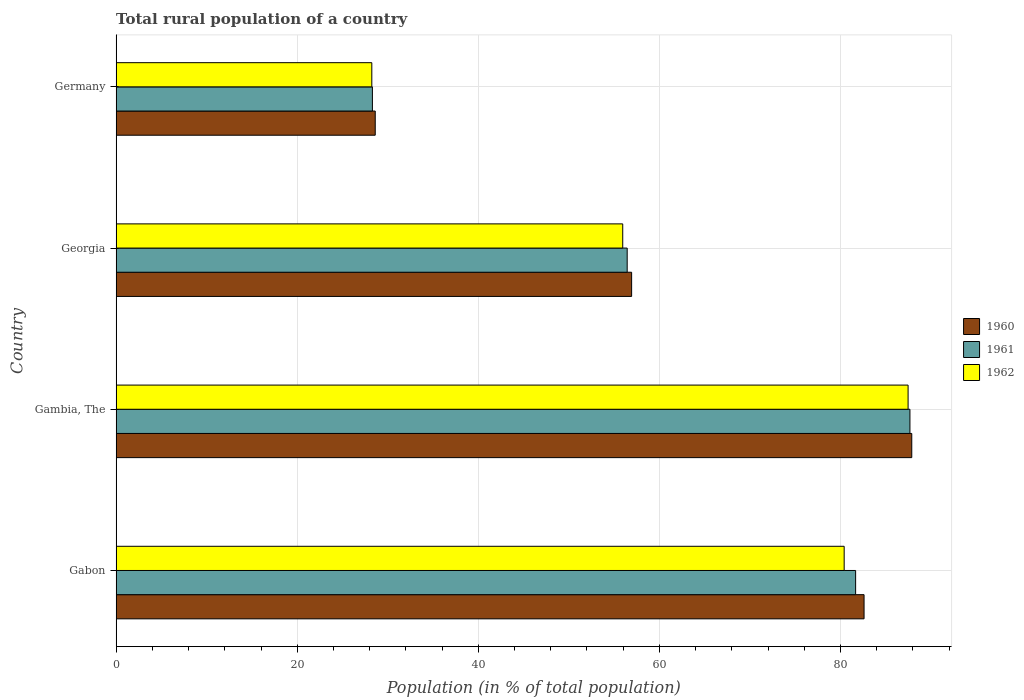How many different coloured bars are there?
Give a very brief answer. 3. How many groups of bars are there?
Your response must be concise. 4. Are the number of bars per tick equal to the number of legend labels?
Give a very brief answer. Yes. Are the number of bars on each tick of the Y-axis equal?
Ensure brevity in your answer.  Yes. How many bars are there on the 3rd tick from the top?
Your response must be concise. 3. How many bars are there on the 3rd tick from the bottom?
Ensure brevity in your answer.  3. What is the label of the 3rd group of bars from the top?
Offer a terse response. Gambia, The. What is the rural population in 1961 in Gambia, The?
Your answer should be compact. 87.67. Across all countries, what is the maximum rural population in 1962?
Your response must be concise. 87.47. Across all countries, what is the minimum rural population in 1962?
Offer a terse response. 28.24. In which country was the rural population in 1960 maximum?
Provide a short and direct response. Gambia, The. What is the total rural population in 1961 in the graph?
Your answer should be compact. 254.08. What is the difference between the rural population in 1962 in Gabon and that in Gambia, The?
Ensure brevity in your answer.  -7.06. What is the difference between the rural population in 1960 in Germany and the rural population in 1962 in Georgia?
Provide a short and direct response. -27.33. What is the average rural population in 1962 per country?
Keep it short and to the point. 63.01. What is the difference between the rural population in 1961 and rural population in 1960 in Germany?
Your response must be concise. -0.31. What is the ratio of the rural population in 1961 in Gabon to that in Georgia?
Offer a terse response. 1.45. Is the rural population in 1960 in Gabon less than that in Georgia?
Your answer should be compact. No. Is the difference between the rural population in 1961 in Gabon and Georgia greater than the difference between the rural population in 1960 in Gabon and Georgia?
Keep it short and to the point. No. What is the difference between the highest and the second highest rural population in 1960?
Ensure brevity in your answer.  5.27. What is the difference between the highest and the lowest rural population in 1961?
Keep it short and to the point. 59.37. In how many countries, is the rural population in 1960 greater than the average rural population in 1960 taken over all countries?
Your answer should be very brief. 2. How many bars are there?
Offer a terse response. 12. Are all the bars in the graph horizontal?
Make the answer very short. Yes. How many countries are there in the graph?
Your answer should be very brief. 4. Are the values on the major ticks of X-axis written in scientific E-notation?
Provide a short and direct response. No. Does the graph contain any zero values?
Your answer should be very brief. No. Does the graph contain grids?
Offer a very short reply. Yes. Where does the legend appear in the graph?
Ensure brevity in your answer.  Center right. How are the legend labels stacked?
Ensure brevity in your answer.  Vertical. What is the title of the graph?
Provide a succinct answer. Total rural population of a country. Does "1990" appear as one of the legend labels in the graph?
Make the answer very short. No. What is the label or title of the X-axis?
Ensure brevity in your answer.  Population (in % of total population). What is the Population (in % of total population) of 1960 in Gabon?
Keep it short and to the point. 82.6. What is the Population (in % of total population) in 1961 in Gabon?
Give a very brief answer. 81.67. What is the Population (in % of total population) of 1962 in Gabon?
Your response must be concise. 80.41. What is the Population (in % of total population) of 1960 in Gambia, The?
Offer a very short reply. 87.87. What is the Population (in % of total population) in 1961 in Gambia, The?
Provide a succinct answer. 87.67. What is the Population (in % of total population) in 1962 in Gambia, The?
Your answer should be very brief. 87.47. What is the Population (in % of total population) of 1960 in Georgia?
Ensure brevity in your answer.  56.93. What is the Population (in % of total population) in 1961 in Georgia?
Your answer should be very brief. 56.44. What is the Population (in % of total population) of 1962 in Georgia?
Give a very brief answer. 55.95. What is the Population (in % of total population) of 1960 in Germany?
Provide a short and direct response. 28.62. What is the Population (in % of total population) in 1961 in Germany?
Provide a succinct answer. 28.3. What is the Population (in % of total population) of 1962 in Germany?
Keep it short and to the point. 28.24. Across all countries, what is the maximum Population (in % of total population) of 1960?
Offer a terse response. 87.87. Across all countries, what is the maximum Population (in % of total population) in 1961?
Your answer should be compact. 87.67. Across all countries, what is the maximum Population (in % of total population) of 1962?
Your answer should be very brief. 87.47. Across all countries, what is the minimum Population (in % of total population) in 1960?
Make the answer very short. 28.62. Across all countries, what is the minimum Population (in % of total population) of 1961?
Make the answer very short. 28.3. Across all countries, what is the minimum Population (in % of total population) of 1962?
Ensure brevity in your answer.  28.24. What is the total Population (in % of total population) of 1960 in the graph?
Make the answer very short. 256.02. What is the total Population (in % of total population) of 1961 in the graph?
Give a very brief answer. 254.08. What is the total Population (in % of total population) in 1962 in the graph?
Your answer should be compact. 252.06. What is the difference between the Population (in % of total population) in 1960 in Gabon and that in Gambia, The?
Provide a short and direct response. -5.27. What is the difference between the Population (in % of total population) of 1961 in Gabon and that in Gambia, The?
Keep it short and to the point. -6. What is the difference between the Population (in % of total population) of 1962 in Gabon and that in Gambia, The?
Offer a very short reply. -7.06. What is the difference between the Population (in % of total population) in 1960 in Gabon and that in Georgia?
Your answer should be compact. 25.67. What is the difference between the Population (in % of total population) in 1961 in Gabon and that in Georgia?
Your answer should be compact. 25.23. What is the difference between the Population (in % of total population) of 1962 in Gabon and that in Georgia?
Keep it short and to the point. 24.46. What is the difference between the Population (in % of total population) of 1960 in Gabon and that in Germany?
Ensure brevity in your answer.  53.99. What is the difference between the Population (in % of total population) in 1961 in Gabon and that in Germany?
Your answer should be compact. 53.37. What is the difference between the Population (in % of total population) of 1962 in Gabon and that in Germany?
Make the answer very short. 52.17. What is the difference between the Population (in % of total population) of 1960 in Gambia, The and that in Georgia?
Keep it short and to the point. 30.94. What is the difference between the Population (in % of total population) in 1961 in Gambia, The and that in Georgia?
Offer a very short reply. 31.23. What is the difference between the Population (in % of total population) of 1962 in Gambia, The and that in Georgia?
Give a very brief answer. 31.52. What is the difference between the Population (in % of total population) in 1960 in Gambia, The and that in Germany?
Your answer should be compact. 59.26. What is the difference between the Population (in % of total population) in 1961 in Gambia, The and that in Germany?
Offer a terse response. 59.37. What is the difference between the Population (in % of total population) of 1962 in Gambia, The and that in Germany?
Keep it short and to the point. 59.23. What is the difference between the Population (in % of total population) of 1960 in Georgia and that in Germany?
Your answer should be compact. 28.32. What is the difference between the Population (in % of total population) of 1961 in Georgia and that in Germany?
Provide a short and direct response. 28.14. What is the difference between the Population (in % of total population) of 1962 in Georgia and that in Germany?
Offer a terse response. 27.71. What is the difference between the Population (in % of total population) in 1960 in Gabon and the Population (in % of total population) in 1961 in Gambia, The?
Offer a very short reply. -5.07. What is the difference between the Population (in % of total population) in 1960 in Gabon and the Population (in % of total population) in 1962 in Gambia, The?
Ensure brevity in your answer.  -4.86. What is the difference between the Population (in % of total population) in 1961 in Gabon and the Population (in % of total population) in 1962 in Gambia, The?
Make the answer very short. -5.79. What is the difference between the Population (in % of total population) of 1960 in Gabon and the Population (in % of total population) of 1961 in Georgia?
Ensure brevity in your answer.  26.16. What is the difference between the Population (in % of total population) of 1960 in Gabon and the Population (in % of total population) of 1962 in Georgia?
Your answer should be compact. 26.65. What is the difference between the Population (in % of total population) of 1961 in Gabon and the Population (in % of total population) of 1962 in Georgia?
Keep it short and to the point. 25.72. What is the difference between the Population (in % of total population) of 1960 in Gabon and the Population (in % of total population) of 1961 in Germany?
Your answer should be very brief. 54.3. What is the difference between the Population (in % of total population) of 1960 in Gabon and the Population (in % of total population) of 1962 in Germany?
Give a very brief answer. 54.36. What is the difference between the Population (in % of total population) in 1961 in Gabon and the Population (in % of total population) in 1962 in Germany?
Give a very brief answer. 53.43. What is the difference between the Population (in % of total population) of 1960 in Gambia, The and the Population (in % of total population) of 1961 in Georgia?
Your response must be concise. 31.43. What is the difference between the Population (in % of total population) of 1960 in Gambia, The and the Population (in % of total population) of 1962 in Georgia?
Your response must be concise. 31.92. What is the difference between the Population (in % of total population) of 1961 in Gambia, The and the Population (in % of total population) of 1962 in Georgia?
Keep it short and to the point. 31.72. What is the difference between the Population (in % of total population) of 1960 in Gambia, The and the Population (in % of total population) of 1961 in Germany?
Your answer should be very brief. 59.57. What is the difference between the Population (in % of total population) of 1960 in Gambia, The and the Population (in % of total population) of 1962 in Germany?
Offer a very short reply. 59.63. What is the difference between the Population (in % of total population) of 1961 in Gambia, The and the Population (in % of total population) of 1962 in Germany?
Your answer should be compact. 59.43. What is the difference between the Population (in % of total population) in 1960 in Georgia and the Population (in % of total population) in 1961 in Germany?
Give a very brief answer. 28.63. What is the difference between the Population (in % of total population) of 1960 in Georgia and the Population (in % of total population) of 1962 in Germany?
Provide a succinct answer. 28.69. What is the difference between the Population (in % of total population) in 1961 in Georgia and the Population (in % of total population) in 1962 in Germany?
Give a very brief answer. 28.2. What is the average Population (in % of total population) of 1960 per country?
Provide a succinct answer. 64. What is the average Population (in % of total population) of 1961 per country?
Your response must be concise. 63.52. What is the average Population (in % of total population) in 1962 per country?
Ensure brevity in your answer.  63.01. What is the difference between the Population (in % of total population) in 1960 and Population (in % of total population) in 1961 in Gabon?
Give a very brief answer. 0.93. What is the difference between the Population (in % of total population) of 1960 and Population (in % of total population) of 1962 in Gabon?
Your answer should be compact. 2.2. What is the difference between the Population (in % of total population) of 1961 and Population (in % of total population) of 1962 in Gabon?
Give a very brief answer. 1.26. What is the difference between the Population (in % of total population) in 1960 and Population (in % of total population) in 1961 in Gambia, The?
Give a very brief answer. 0.2. What is the difference between the Population (in % of total population) of 1960 and Population (in % of total population) of 1962 in Gambia, The?
Your response must be concise. 0.41. What is the difference between the Population (in % of total population) of 1961 and Population (in % of total population) of 1962 in Gambia, The?
Ensure brevity in your answer.  0.2. What is the difference between the Population (in % of total population) in 1960 and Population (in % of total population) in 1961 in Georgia?
Your answer should be compact. 0.49. What is the difference between the Population (in % of total population) in 1960 and Population (in % of total population) in 1962 in Georgia?
Offer a terse response. 0.98. What is the difference between the Population (in % of total population) of 1961 and Population (in % of total population) of 1962 in Georgia?
Provide a short and direct response. 0.49. What is the difference between the Population (in % of total population) of 1960 and Population (in % of total population) of 1961 in Germany?
Give a very brief answer. 0.31. What is the difference between the Population (in % of total population) of 1960 and Population (in % of total population) of 1962 in Germany?
Give a very brief answer. 0.38. What is the difference between the Population (in % of total population) in 1961 and Population (in % of total population) in 1962 in Germany?
Offer a very short reply. 0.07. What is the ratio of the Population (in % of total population) of 1961 in Gabon to that in Gambia, The?
Your response must be concise. 0.93. What is the ratio of the Population (in % of total population) in 1962 in Gabon to that in Gambia, The?
Give a very brief answer. 0.92. What is the ratio of the Population (in % of total population) of 1960 in Gabon to that in Georgia?
Your answer should be very brief. 1.45. What is the ratio of the Population (in % of total population) of 1961 in Gabon to that in Georgia?
Ensure brevity in your answer.  1.45. What is the ratio of the Population (in % of total population) of 1962 in Gabon to that in Georgia?
Ensure brevity in your answer.  1.44. What is the ratio of the Population (in % of total population) in 1960 in Gabon to that in Germany?
Your answer should be compact. 2.89. What is the ratio of the Population (in % of total population) of 1961 in Gabon to that in Germany?
Keep it short and to the point. 2.89. What is the ratio of the Population (in % of total population) of 1962 in Gabon to that in Germany?
Your response must be concise. 2.85. What is the ratio of the Population (in % of total population) of 1960 in Gambia, The to that in Georgia?
Your answer should be very brief. 1.54. What is the ratio of the Population (in % of total population) in 1961 in Gambia, The to that in Georgia?
Provide a short and direct response. 1.55. What is the ratio of the Population (in % of total population) of 1962 in Gambia, The to that in Georgia?
Provide a short and direct response. 1.56. What is the ratio of the Population (in % of total population) of 1960 in Gambia, The to that in Germany?
Give a very brief answer. 3.07. What is the ratio of the Population (in % of total population) of 1961 in Gambia, The to that in Germany?
Keep it short and to the point. 3.1. What is the ratio of the Population (in % of total population) of 1962 in Gambia, The to that in Germany?
Offer a terse response. 3.1. What is the ratio of the Population (in % of total population) of 1960 in Georgia to that in Germany?
Make the answer very short. 1.99. What is the ratio of the Population (in % of total population) of 1961 in Georgia to that in Germany?
Ensure brevity in your answer.  1.99. What is the ratio of the Population (in % of total population) in 1962 in Georgia to that in Germany?
Your response must be concise. 1.98. What is the difference between the highest and the second highest Population (in % of total population) in 1960?
Keep it short and to the point. 5.27. What is the difference between the highest and the second highest Population (in % of total population) in 1961?
Your answer should be very brief. 6. What is the difference between the highest and the second highest Population (in % of total population) in 1962?
Your response must be concise. 7.06. What is the difference between the highest and the lowest Population (in % of total population) in 1960?
Ensure brevity in your answer.  59.26. What is the difference between the highest and the lowest Population (in % of total population) of 1961?
Your response must be concise. 59.37. What is the difference between the highest and the lowest Population (in % of total population) of 1962?
Give a very brief answer. 59.23. 